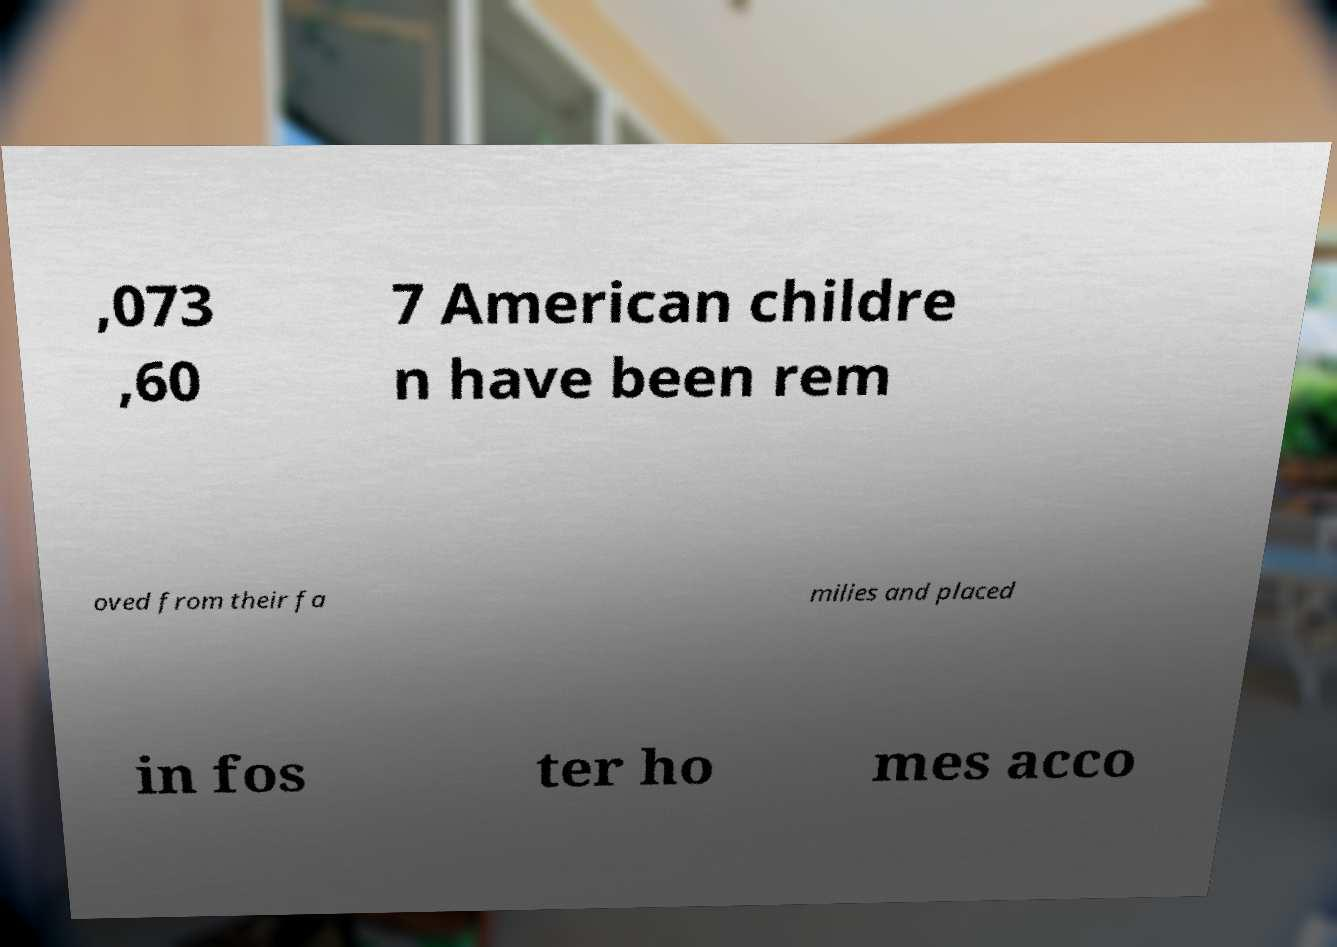Could you extract and type out the text from this image? ,073 ,60 7 American childre n have been rem oved from their fa milies and placed in fos ter ho mes acco 